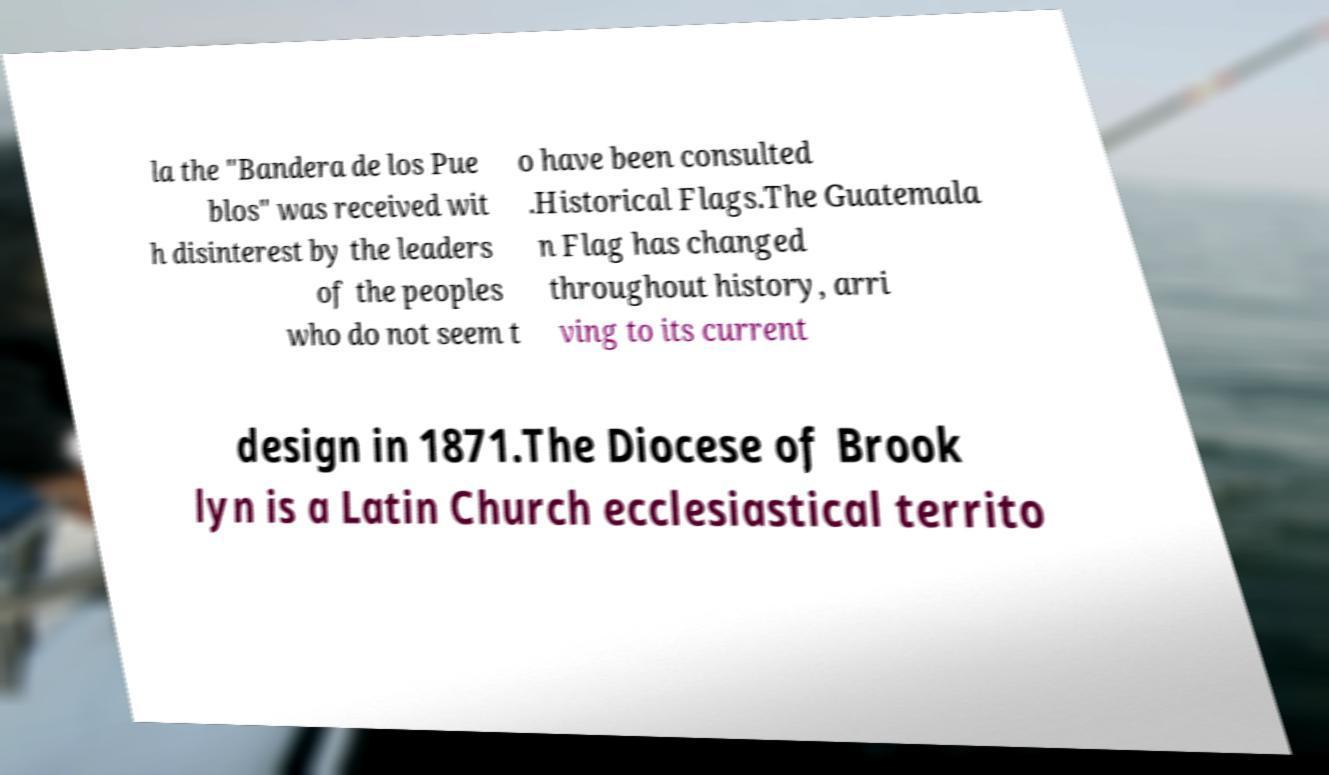Could you assist in decoding the text presented in this image and type it out clearly? la the "Bandera de los Pue blos" was received wit h disinterest by the leaders of the peoples who do not seem t o have been consulted .Historical Flags.The Guatemala n Flag has changed throughout history, arri ving to its current design in 1871.The Diocese of Brook lyn is a Latin Church ecclesiastical territo 